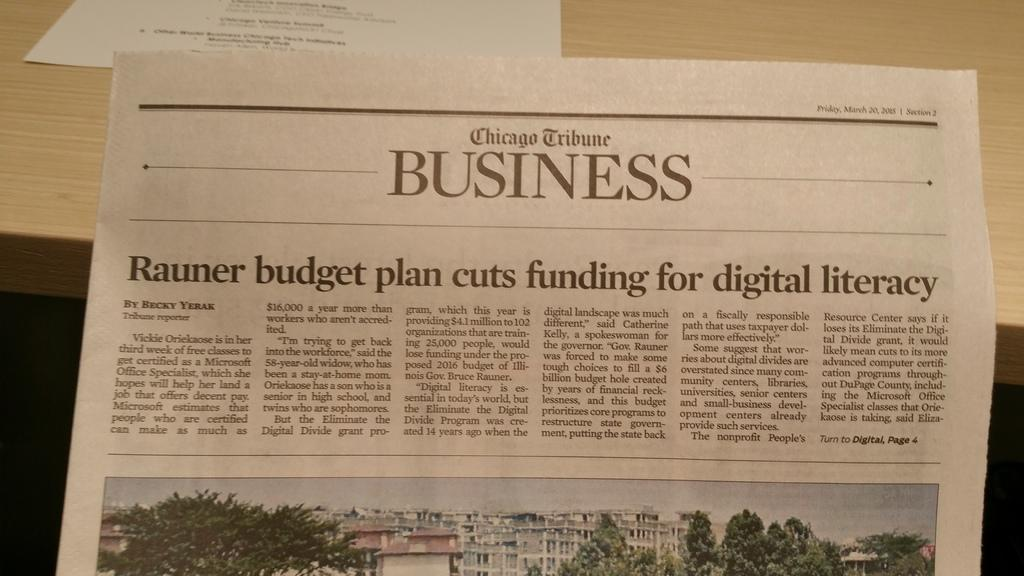<image>
Present a compact description of the photo's key features. The news on Friday, March 20, 2015 was that the Rauner budget plan cuts funding for digital literacy. 